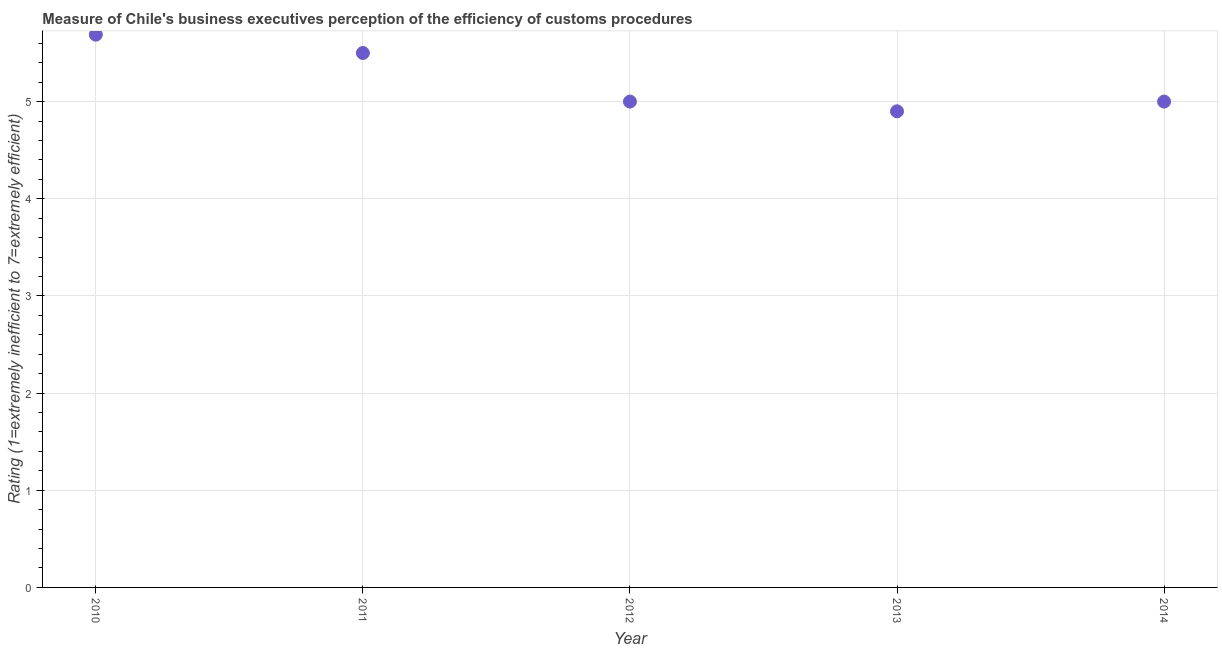Across all years, what is the maximum rating measuring burden of customs procedure?
Offer a very short reply. 5.69. Across all years, what is the minimum rating measuring burden of customs procedure?
Your answer should be very brief. 4.9. What is the sum of the rating measuring burden of customs procedure?
Offer a very short reply. 26.09. What is the difference between the rating measuring burden of customs procedure in 2012 and 2013?
Make the answer very short. 0.1. What is the average rating measuring burden of customs procedure per year?
Make the answer very short. 5.22. What is the ratio of the rating measuring burden of customs procedure in 2011 to that in 2012?
Keep it short and to the point. 1.1. Is the rating measuring burden of customs procedure in 2011 less than that in 2014?
Provide a short and direct response. No. What is the difference between the highest and the second highest rating measuring burden of customs procedure?
Your answer should be compact. 0.19. What is the difference between the highest and the lowest rating measuring burden of customs procedure?
Your response must be concise. 0.79. Does the rating measuring burden of customs procedure monotonically increase over the years?
Your response must be concise. No. How many dotlines are there?
Make the answer very short. 1. What is the difference between two consecutive major ticks on the Y-axis?
Provide a short and direct response. 1. Does the graph contain grids?
Your response must be concise. Yes. What is the title of the graph?
Provide a succinct answer. Measure of Chile's business executives perception of the efficiency of customs procedures. What is the label or title of the Y-axis?
Give a very brief answer. Rating (1=extremely inefficient to 7=extremely efficient). What is the Rating (1=extremely inefficient to 7=extremely efficient) in 2010?
Provide a short and direct response. 5.69. What is the Rating (1=extremely inefficient to 7=extremely efficient) in 2011?
Your answer should be compact. 5.5. What is the Rating (1=extremely inefficient to 7=extremely efficient) in 2013?
Your answer should be compact. 4.9. What is the difference between the Rating (1=extremely inefficient to 7=extremely efficient) in 2010 and 2011?
Your response must be concise. 0.19. What is the difference between the Rating (1=extremely inefficient to 7=extremely efficient) in 2010 and 2012?
Ensure brevity in your answer.  0.69. What is the difference between the Rating (1=extremely inefficient to 7=extremely efficient) in 2010 and 2013?
Make the answer very short. 0.79. What is the difference between the Rating (1=extremely inefficient to 7=extremely efficient) in 2010 and 2014?
Your answer should be compact. 0.69. What is the difference between the Rating (1=extremely inefficient to 7=extremely efficient) in 2011 and 2012?
Your answer should be compact. 0.5. What is the difference between the Rating (1=extremely inefficient to 7=extremely efficient) in 2011 and 2013?
Make the answer very short. 0.6. What is the difference between the Rating (1=extremely inefficient to 7=extremely efficient) in 2013 and 2014?
Your response must be concise. -0.1. What is the ratio of the Rating (1=extremely inefficient to 7=extremely efficient) in 2010 to that in 2011?
Your answer should be compact. 1.03. What is the ratio of the Rating (1=extremely inefficient to 7=extremely efficient) in 2010 to that in 2012?
Your answer should be very brief. 1.14. What is the ratio of the Rating (1=extremely inefficient to 7=extremely efficient) in 2010 to that in 2013?
Provide a short and direct response. 1.16. What is the ratio of the Rating (1=extremely inefficient to 7=extremely efficient) in 2010 to that in 2014?
Offer a terse response. 1.14. What is the ratio of the Rating (1=extremely inefficient to 7=extremely efficient) in 2011 to that in 2012?
Offer a very short reply. 1.1. What is the ratio of the Rating (1=extremely inefficient to 7=extremely efficient) in 2011 to that in 2013?
Make the answer very short. 1.12. What is the ratio of the Rating (1=extremely inefficient to 7=extremely efficient) in 2011 to that in 2014?
Offer a very short reply. 1.1. What is the ratio of the Rating (1=extremely inefficient to 7=extremely efficient) in 2012 to that in 2014?
Your answer should be very brief. 1. What is the ratio of the Rating (1=extremely inefficient to 7=extremely efficient) in 2013 to that in 2014?
Your answer should be very brief. 0.98. 